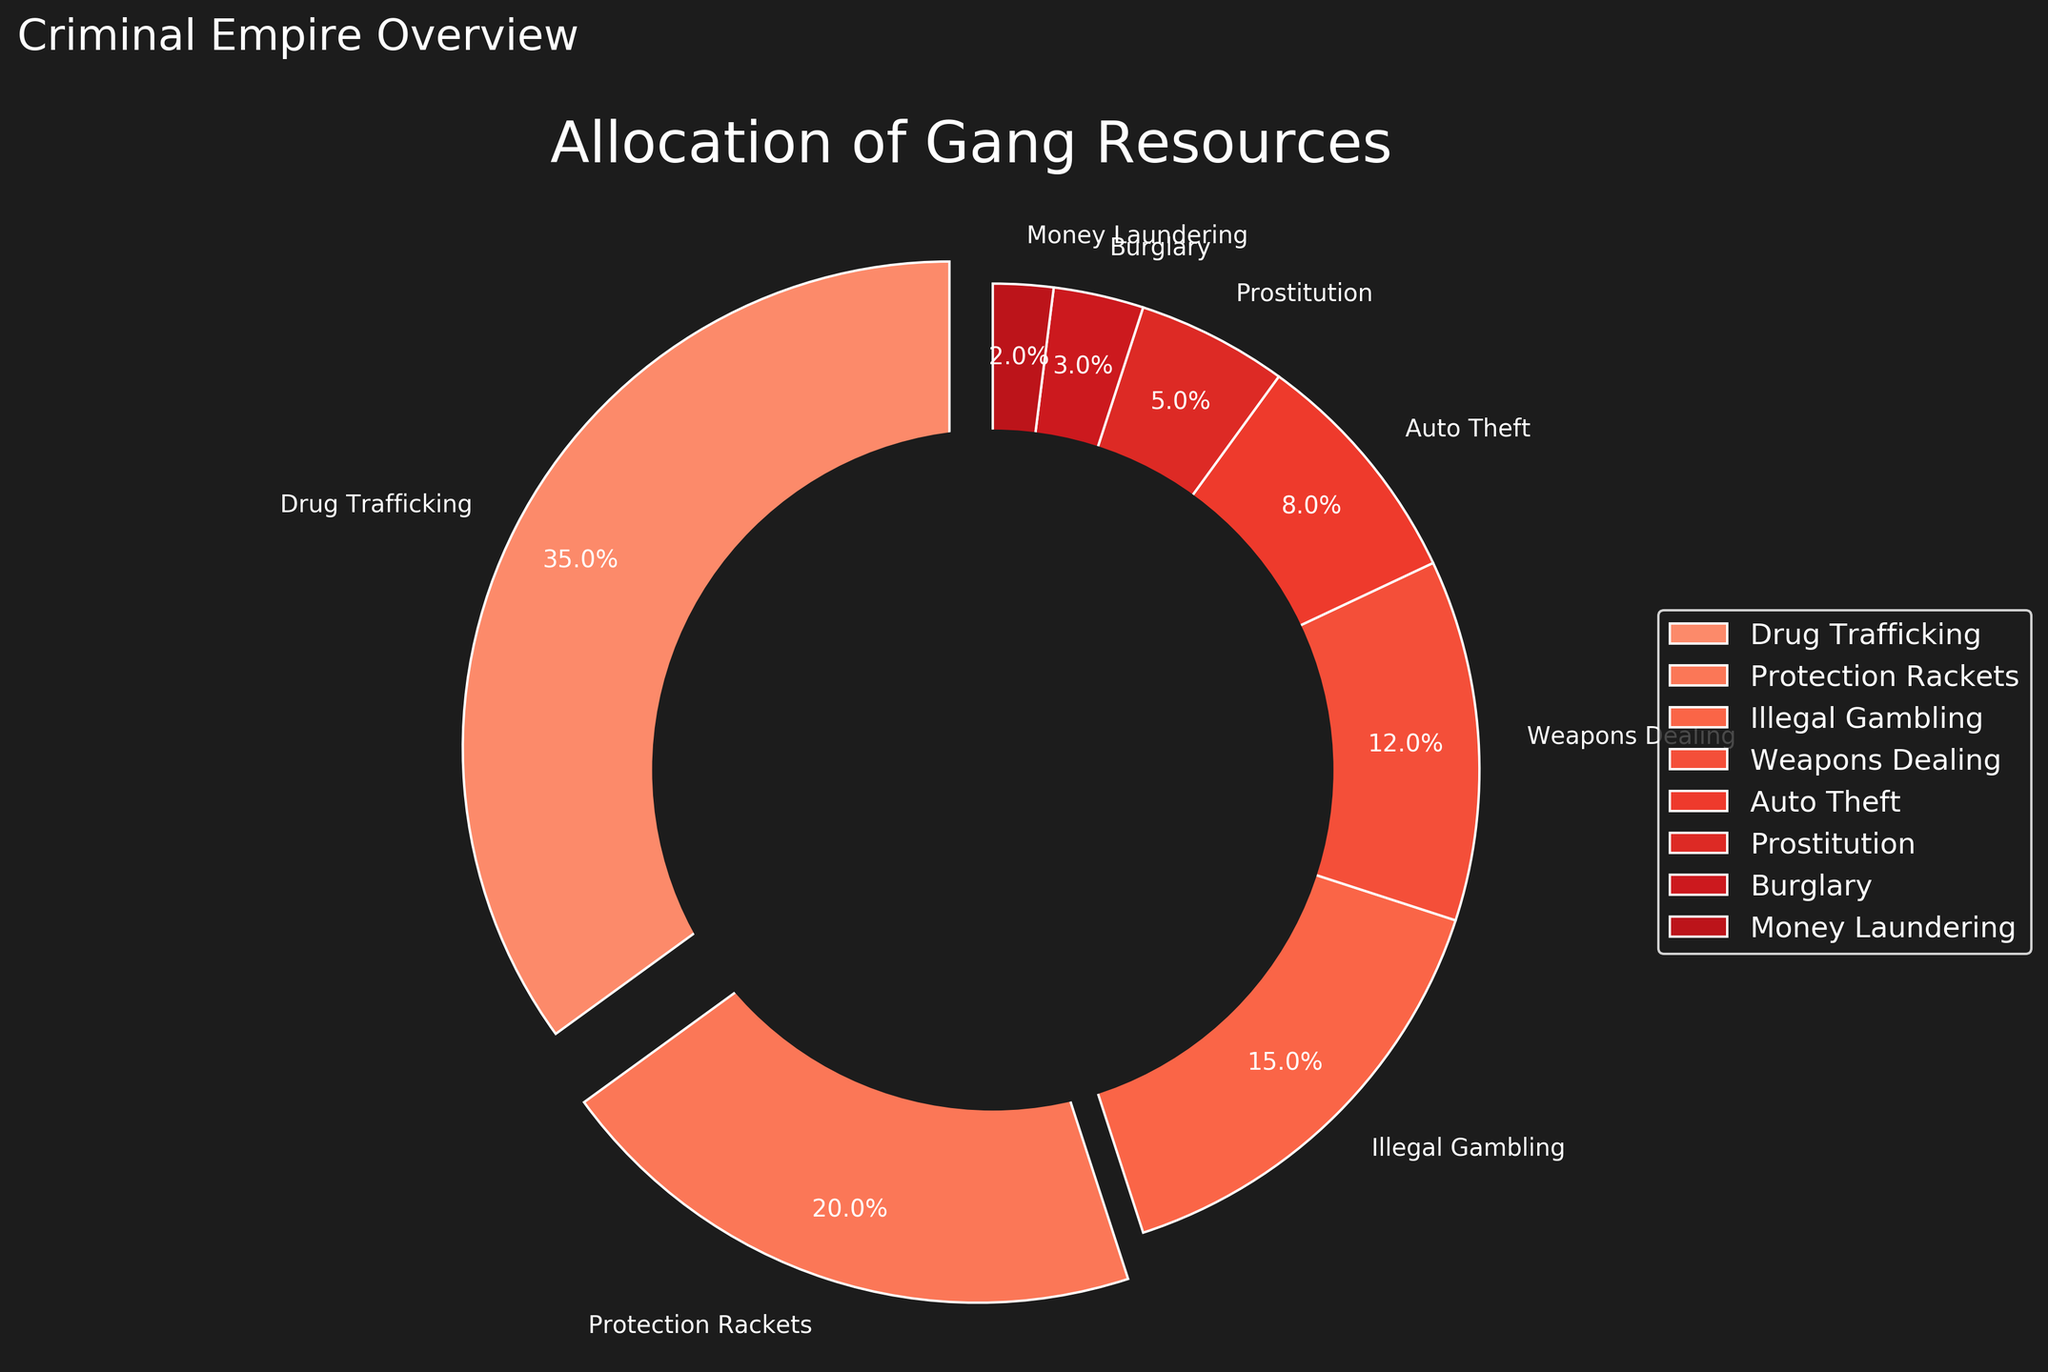what percentage of resources is allocated to drug trafficking and protection rackets combined? First, locate the percentages for "Drug Trafficking" and "Protection Rackets" in the figure, which are 35% and 20%, respectively. Then, sum these percentages: 35% + 20% = 55%.
Answer: 55% what is the difference in resource allocation between illegal gambling and auto theft? Find the percentages for "Illegal Gambling" (15%) and "Auto Theft" (8%). Subtract the smaller value from the larger: 15% - 8% = 7%.
Answer: 7% which activity has the lowest allocation of resources, and what percentage is it? Look at the slices in the pie chart and identify the smallest one. "Money Laundering" is the smallest slice with a percentage of 2%.
Answer: Money Laundering, 2% how much more is allocated to weapons dealing compared to prostitution? Identify the percentages for "Weapons Dealing" (12%) and "Prostitution" (5%). Subtract the smaller percentage from the larger: 12% - 5% = 7%.
Answer: 7% compare the allocation to weapons dealing and auto theft. which one has a higher percentage? Check the percentages for "Weapons Dealing" (12%) and "Auto Theft" (8%). Since 12% is greater than 8%, "Weapons Dealing" has a higher percentage.
Answer: Weapons Dealing which activity receives the third highest allocation? Observe the percentages of each activity and rank them in descending order. The third highest after "Drug Trafficking" (35%) and "Protection Rackets" (20%) is "Illegal Gambling" (15%).
Answer: Illegal Gambling if the sum of all allocations is 100%, how much is allocated to activities other than drug trafficking? Given that the total allocation is 100%, subtract the percentage for "Drug Trafficking" (35%). Thus, 100% - 35% = 65%.
Answer: 65% what visual elements make drug trafficking stand out in the pie chart? Several visual aspects emphasize "Drug Trafficking." It has an exploded slice (offset from the center) and is one of the larger slices in a more intense red hue.
Answer: exploded slice, larger slice, intense red hue what ratio of resources is allocated to weapons dealing compared to money laundering? Determine the percentages for "Weapons Dealing" (12%) and "Money Laundering" (2%). Calculate the ratio by dividing 12 by 2. The ratio is 12:2, which simplifies to 6:1.
Answer: 6:1 does illegal gambling receive more resources than auto theft and prostitution combined? Check the percentages for "Illegal Gambling" (15%), "Auto Theft" (8%), and "Prostitution" (5%). Sum the latter two: 8% + 5% = 13%. Since 15% > 13%, "Illegal Gambling" receives more resources.
Answer: Yes 